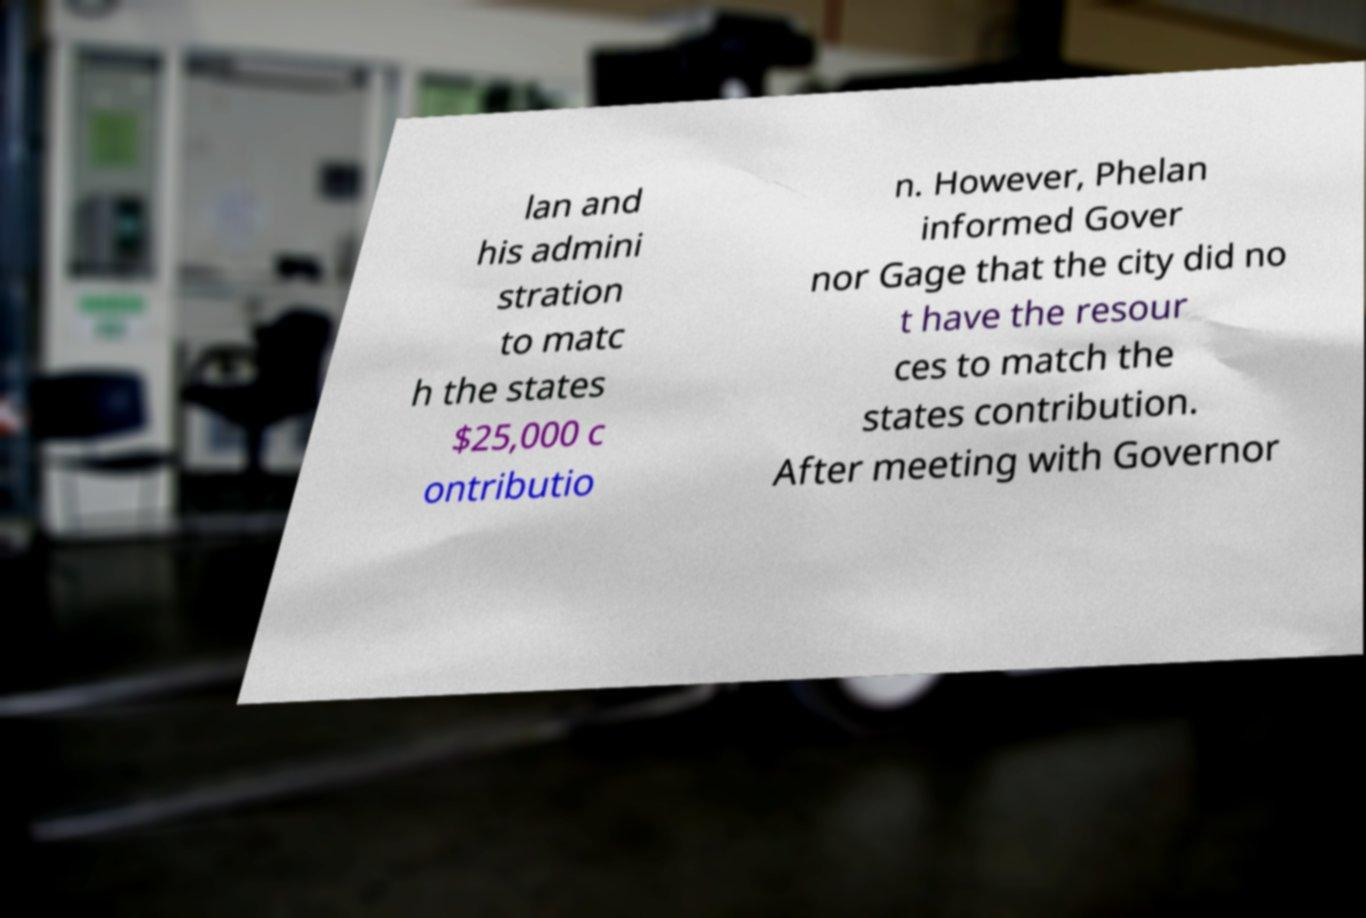Please read and relay the text visible in this image. What does it say? lan and his admini stration to matc h the states $25,000 c ontributio n. However, Phelan informed Gover nor Gage that the city did no t have the resour ces to match the states contribution. After meeting with Governor 